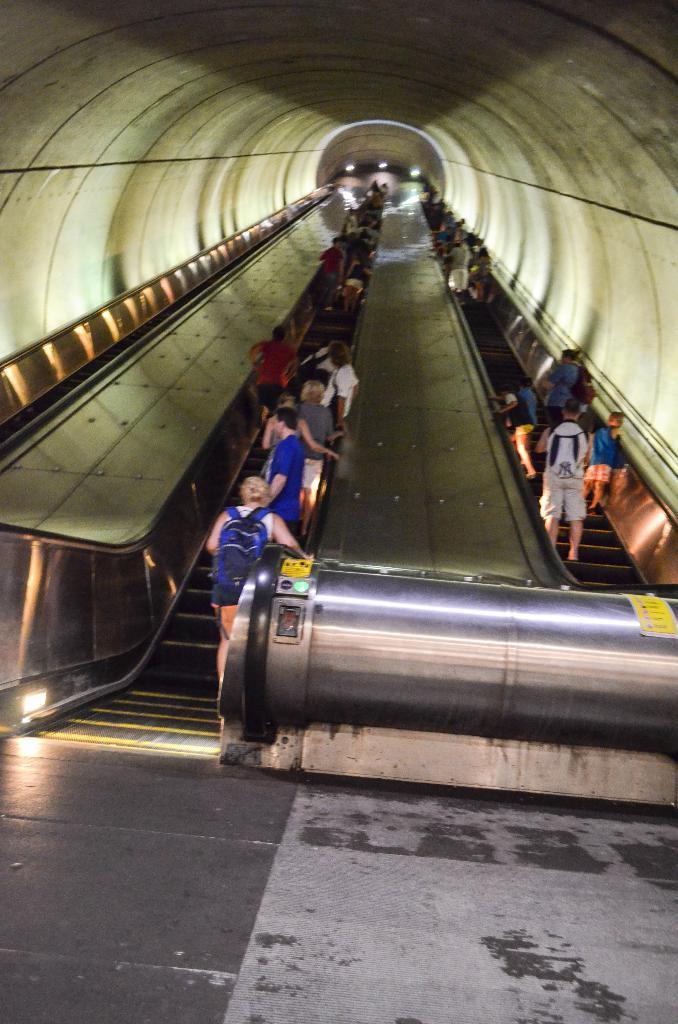Can you describe this image briefly? In this image I can see stairs, few yellow colour things and number of people are standing. I can see few of them are carrying bags. 